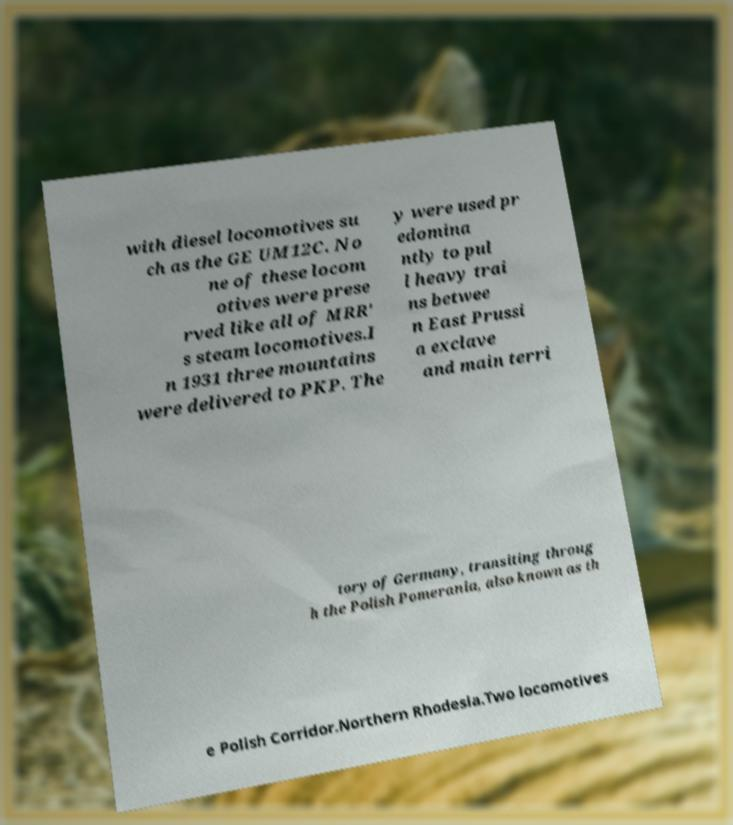Please read and relay the text visible in this image. What does it say? with diesel locomotives su ch as the GE UM12C. No ne of these locom otives were prese rved like all of MRR' s steam locomotives.I n 1931 three mountains were delivered to PKP. The y were used pr edomina ntly to pul l heavy trai ns betwee n East Prussi a exclave and main terri tory of Germany, transiting throug h the Polish Pomerania, also known as th e Polish Corridor.Northern Rhodesia.Two locomotives 